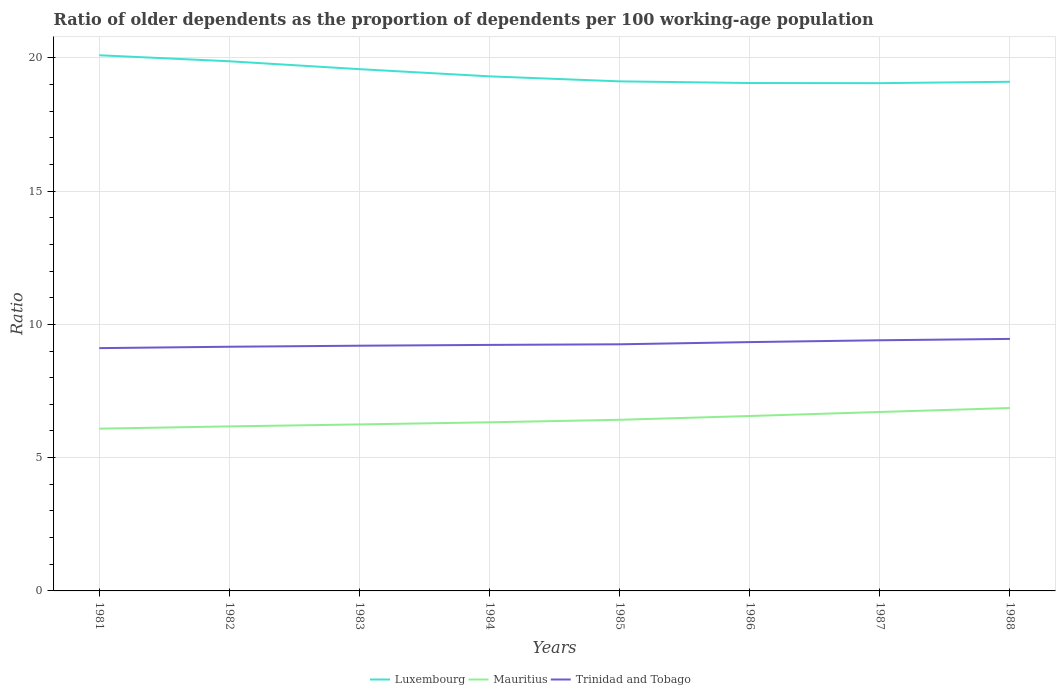How many different coloured lines are there?
Your response must be concise. 3. Is the number of lines equal to the number of legend labels?
Your response must be concise. Yes. Across all years, what is the maximum age dependency ratio(old) in Trinidad and Tobago?
Keep it short and to the point. 9.11. What is the total age dependency ratio(old) in Mauritius in the graph?
Offer a very short reply. -0.39. What is the difference between the highest and the second highest age dependency ratio(old) in Luxembourg?
Offer a very short reply. 1.05. What is the difference between the highest and the lowest age dependency ratio(old) in Luxembourg?
Make the answer very short. 3. Is the age dependency ratio(old) in Trinidad and Tobago strictly greater than the age dependency ratio(old) in Mauritius over the years?
Give a very brief answer. No. Are the values on the major ticks of Y-axis written in scientific E-notation?
Provide a succinct answer. No. What is the title of the graph?
Provide a short and direct response. Ratio of older dependents as the proportion of dependents per 100 working-age population. Does "Low income" appear as one of the legend labels in the graph?
Offer a terse response. No. What is the label or title of the Y-axis?
Your answer should be very brief. Ratio. What is the Ratio in Luxembourg in 1981?
Keep it short and to the point. 20.1. What is the Ratio in Mauritius in 1981?
Ensure brevity in your answer.  6.09. What is the Ratio of Trinidad and Tobago in 1981?
Keep it short and to the point. 9.11. What is the Ratio in Luxembourg in 1982?
Keep it short and to the point. 19.87. What is the Ratio in Mauritius in 1982?
Ensure brevity in your answer.  6.17. What is the Ratio of Trinidad and Tobago in 1982?
Offer a terse response. 9.16. What is the Ratio in Luxembourg in 1983?
Make the answer very short. 19.57. What is the Ratio in Mauritius in 1983?
Keep it short and to the point. 6.25. What is the Ratio of Trinidad and Tobago in 1983?
Keep it short and to the point. 9.2. What is the Ratio in Luxembourg in 1984?
Your answer should be very brief. 19.3. What is the Ratio in Mauritius in 1984?
Provide a short and direct response. 6.33. What is the Ratio of Trinidad and Tobago in 1984?
Your answer should be very brief. 9.23. What is the Ratio in Luxembourg in 1985?
Offer a terse response. 19.12. What is the Ratio of Mauritius in 1985?
Keep it short and to the point. 6.42. What is the Ratio of Trinidad and Tobago in 1985?
Your answer should be compact. 9.25. What is the Ratio of Luxembourg in 1986?
Give a very brief answer. 19.05. What is the Ratio in Mauritius in 1986?
Provide a succinct answer. 6.56. What is the Ratio of Trinidad and Tobago in 1986?
Keep it short and to the point. 9.33. What is the Ratio of Luxembourg in 1987?
Provide a succinct answer. 19.05. What is the Ratio in Mauritius in 1987?
Offer a terse response. 6.71. What is the Ratio in Trinidad and Tobago in 1987?
Make the answer very short. 9.4. What is the Ratio in Luxembourg in 1988?
Offer a very short reply. 19.1. What is the Ratio of Mauritius in 1988?
Your answer should be very brief. 6.86. What is the Ratio of Trinidad and Tobago in 1988?
Keep it short and to the point. 9.45. Across all years, what is the maximum Ratio in Luxembourg?
Your response must be concise. 20.1. Across all years, what is the maximum Ratio of Mauritius?
Your answer should be very brief. 6.86. Across all years, what is the maximum Ratio of Trinidad and Tobago?
Ensure brevity in your answer.  9.45. Across all years, what is the minimum Ratio of Luxembourg?
Make the answer very short. 19.05. Across all years, what is the minimum Ratio in Mauritius?
Ensure brevity in your answer.  6.09. Across all years, what is the minimum Ratio in Trinidad and Tobago?
Your response must be concise. 9.11. What is the total Ratio in Luxembourg in the graph?
Provide a succinct answer. 155.16. What is the total Ratio in Mauritius in the graph?
Keep it short and to the point. 51.39. What is the total Ratio in Trinidad and Tobago in the graph?
Your answer should be very brief. 74.14. What is the difference between the Ratio in Luxembourg in 1981 and that in 1982?
Keep it short and to the point. 0.23. What is the difference between the Ratio of Mauritius in 1981 and that in 1982?
Provide a short and direct response. -0.09. What is the difference between the Ratio in Trinidad and Tobago in 1981 and that in 1982?
Make the answer very short. -0.05. What is the difference between the Ratio of Luxembourg in 1981 and that in 1983?
Make the answer very short. 0.52. What is the difference between the Ratio in Mauritius in 1981 and that in 1983?
Your response must be concise. -0.16. What is the difference between the Ratio of Trinidad and Tobago in 1981 and that in 1983?
Offer a terse response. -0.09. What is the difference between the Ratio in Luxembourg in 1981 and that in 1984?
Your response must be concise. 0.79. What is the difference between the Ratio in Mauritius in 1981 and that in 1984?
Keep it short and to the point. -0.24. What is the difference between the Ratio in Trinidad and Tobago in 1981 and that in 1984?
Provide a succinct answer. -0.12. What is the difference between the Ratio of Luxembourg in 1981 and that in 1985?
Keep it short and to the point. 0.98. What is the difference between the Ratio in Mauritius in 1981 and that in 1985?
Offer a very short reply. -0.33. What is the difference between the Ratio in Trinidad and Tobago in 1981 and that in 1985?
Ensure brevity in your answer.  -0.14. What is the difference between the Ratio of Luxembourg in 1981 and that in 1986?
Offer a terse response. 1.04. What is the difference between the Ratio in Mauritius in 1981 and that in 1986?
Offer a terse response. -0.48. What is the difference between the Ratio of Trinidad and Tobago in 1981 and that in 1986?
Ensure brevity in your answer.  -0.23. What is the difference between the Ratio in Luxembourg in 1981 and that in 1987?
Ensure brevity in your answer.  1.05. What is the difference between the Ratio of Mauritius in 1981 and that in 1987?
Your answer should be compact. -0.63. What is the difference between the Ratio of Trinidad and Tobago in 1981 and that in 1987?
Give a very brief answer. -0.29. What is the difference between the Ratio of Mauritius in 1981 and that in 1988?
Offer a terse response. -0.77. What is the difference between the Ratio in Trinidad and Tobago in 1981 and that in 1988?
Your answer should be very brief. -0.35. What is the difference between the Ratio in Luxembourg in 1982 and that in 1983?
Your response must be concise. 0.3. What is the difference between the Ratio in Mauritius in 1982 and that in 1983?
Make the answer very short. -0.07. What is the difference between the Ratio in Trinidad and Tobago in 1982 and that in 1983?
Offer a very short reply. -0.04. What is the difference between the Ratio in Luxembourg in 1982 and that in 1984?
Keep it short and to the point. 0.57. What is the difference between the Ratio of Mauritius in 1982 and that in 1984?
Your answer should be very brief. -0.15. What is the difference between the Ratio of Trinidad and Tobago in 1982 and that in 1984?
Offer a very short reply. -0.07. What is the difference between the Ratio of Luxembourg in 1982 and that in 1985?
Offer a terse response. 0.75. What is the difference between the Ratio in Mauritius in 1982 and that in 1985?
Your answer should be compact. -0.25. What is the difference between the Ratio of Trinidad and Tobago in 1982 and that in 1985?
Provide a short and direct response. -0.09. What is the difference between the Ratio of Luxembourg in 1982 and that in 1986?
Keep it short and to the point. 0.82. What is the difference between the Ratio in Mauritius in 1982 and that in 1986?
Keep it short and to the point. -0.39. What is the difference between the Ratio of Trinidad and Tobago in 1982 and that in 1986?
Your answer should be compact. -0.17. What is the difference between the Ratio of Luxembourg in 1982 and that in 1987?
Provide a succinct answer. 0.82. What is the difference between the Ratio in Mauritius in 1982 and that in 1987?
Provide a succinct answer. -0.54. What is the difference between the Ratio in Trinidad and Tobago in 1982 and that in 1987?
Your response must be concise. -0.24. What is the difference between the Ratio in Luxembourg in 1982 and that in 1988?
Give a very brief answer. 0.77. What is the difference between the Ratio in Mauritius in 1982 and that in 1988?
Ensure brevity in your answer.  -0.69. What is the difference between the Ratio of Trinidad and Tobago in 1982 and that in 1988?
Make the answer very short. -0.29. What is the difference between the Ratio of Luxembourg in 1983 and that in 1984?
Offer a terse response. 0.27. What is the difference between the Ratio in Mauritius in 1983 and that in 1984?
Keep it short and to the point. -0.08. What is the difference between the Ratio of Trinidad and Tobago in 1983 and that in 1984?
Ensure brevity in your answer.  -0.03. What is the difference between the Ratio of Luxembourg in 1983 and that in 1985?
Your answer should be very brief. 0.46. What is the difference between the Ratio of Mauritius in 1983 and that in 1985?
Keep it short and to the point. -0.17. What is the difference between the Ratio in Trinidad and Tobago in 1983 and that in 1985?
Make the answer very short. -0.05. What is the difference between the Ratio of Luxembourg in 1983 and that in 1986?
Make the answer very short. 0.52. What is the difference between the Ratio of Mauritius in 1983 and that in 1986?
Provide a short and direct response. -0.32. What is the difference between the Ratio of Trinidad and Tobago in 1983 and that in 1986?
Your response must be concise. -0.14. What is the difference between the Ratio in Luxembourg in 1983 and that in 1987?
Your response must be concise. 0.52. What is the difference between the Ratio in Mauritius in 1983 and that in 1987?
Offer a terse response. -0.47. What is the difference between the Ratio in Trinidad and Tobago in 1983 and that in 1987?
Make the answer very short. -0.2. What is the difference between the Ratio in Luxembourg in 1983 and that in 1988?
Make the answer very short. 0.47. What is the difference between the Ratio of Mauritius in 1983 and that in 1988?
Your answer should be very brief. -0.61. What is the difference between the Ratio of Trinidad and Tobago in 1983 and that in 1988?
Your response must be concise. -0.25. What is the difference between the Ratio of Luxembourg in 1984 and that in 1985?
Your answer should be compact. 0.19. What is the difference between the Ratio in Mauritius in 1984 and that in 1985?
Your answer should be compact. -0.09. What is the difference between the Ratio of Trinidad and Tobago in 1984 and that in 1985?
Give a very brief answer. -0.02. What is the difference between the Ratio of Luxembourg in 1984 and that in 1986?
Give a very brief answer. 0.25. What is the difference between the Ratio of Mauritius in 1984 and that in 1986?
Ensure brevity in your answer.  -0.24. What is the difference between the Ratio in Trinidad and Tobago in 1984 and that in 1986?
Provide a succinct answer. -0.11. What is the difference between the Ratio of Luxembourg in 1984 and that in 1987?
Offer a terse response. 0.26. What is the difference between the Ratio of Mauritius in 1984 and that in 1987?
Offer a very short reply. -0.39. What is the difference between the Ratio in Trinidad and Tobago in 1984 and that in 1987?
Your answer should be very brief. -0.17. What is the difference between the Ratio in Luxembourg in 1984 and that in 1988?
Ensure brevity in your answer.  0.2. What is the difference between the Ratio of Mauritius in 1984 and that in 1988?
Make the answer very short. -0.54. What is the difference between the Ratio of Trinidad and Tobago in 1984 and that in 1988?
Provide a succinct answer. -0.23. What is the difference between the Ratio in Luxembourg in 1985 and that in 1986?
Your response must be concise. 0.06. What is the difference between the Ratio in Mauritius in 1985 and that in 1986?
Keep it short and to the point. -0.14. What is the difference between the Ratio in Trinidad and Tobago in 1985 and that in 1986?
Offer a terse response. -0.08. What is the difference between the Ratio of Luxembourg in 1985 and that in 1987?
Provide a succinct answer. 0.07. What is the difference between the Ratio in Mauritius in 1985 and that in 1987?
Ensure brevity in your answer.  -0.29. What is the difference between the Ratio of Trinidad and Tobago in 1985 and that in 1987?
Keep it short and to the point. -0.15. What is the difference between the Ratio of Luxembourg in 1985 and that in 1988?
Ensure brevity in your answer.  0.02. What is the difference between the Ratio of Mauritius in 1985 and that in 1988?
Provide a short and direct response. -0.44. What is the difference between the Ratio in Trinidad and Tobago in 1985 and that in 1988?
Your response must be concise. -0.2. What is the difference between the Ratio in Luxembourg in 1986 and that in 1987?
Provide a succinct answer. 0.01. What is the difference between the Ratio of Mauritius in 1986 and that in 1987?
Your response must be concise. -0.15. What is the difference between the Ratio of Trinidad and Tobago in 1986 and that in 1987?
Ensure brevity in your answer.  -0.07. What is the difference between the Ratio in Luxembourg in 1986 and that in 1988?
Make the answer very short. -0.05. What is the difference between the Ratio in Mauritius in 1986 and that in 1988?
Give a very brief answer. -0.3. What is the difference between the Ratio of Trinidad and Tobago in 1986 and that in 1988?
Your answer should be very brief. -0.12. What is the difference between the Ratio of Luxembourg in 1987 and that in 1988?
Your answer should be compact. -0.05. What is the difference between the Ratio in Mauritius in 1987 and that in 1988?
Keep it short and to the point. -0.15. What is the difference between the Ratio in Trinidad and Tobago in 1987 and that in 1988?
Your answer should be compact. -0.05. What is the difference between the Ratio in Luxembourg in 1981 and the Ratio in Mauritius in 1982?
Your answer should be very brief. 13.92. What is the difference between the Ratio in Luxembourg in 1981 and the Ratio in Trinidad and Tobago in 1982?
Provide a short and direct response. 10.93. What is the difference between the Ratio in Mauritius in 1981 and the Ratio in Trinidad and Tobago in 1982?
Your response must be concise. -3.07. What is the difference between the Ratio in Luxembourg in 1981 and the Ratio in Mauritius in 1983?
Give a very brief answer. 13.85. What is the difference between the Ratio in Luxembourg in 1981 and the Ratio in Trinidad and Tobago in 1983?
Make the answer very short. 10.9. What is the difference between the Ratio in Mauritius in 1981 and the Ratio in Trinidad and Tobago in 1983?
Your answer should be compact. -3.11. What is the difference between the Ratio of Luxembourg in 1981 and the Ratio of Mauritius in 1984?
Keep it short and to the point. 13.77. What is the difference between the Ratio in Luxembourg in 1981 and the Ratio in Trinidad and Tobago in 1984?
Offer a very short reply. 10.87. What is the difference between the Ratio in Mauritius in 1981 and the Ratio in Trinidad and Tobago in 1984?
Ensure brevity in your answer.  -3.14. What is the difference between the Ratio in Luxembourg in 1981 and the Ratio in Mauritius in 1985?
Your response must be concise. 13.68. What is the difference between the Ratio in Luxembourg in 1981 and the Ratio in Trinidad and Tobago in 1985?
Ensure brevity in your answer.  10.84. What is the difference between the Ratio of Mauritius in 1981 and the Ratio of Trinidad and Tobago in 1985?
Your answer should be very brief. -3.16. What is the difference between the Ratio of Luxembourg in 1981 and the Ratio of Mauritius in 1986?
Provide a short and direct response. 13.53. What is the difference between the Ratio of Luxembourg in 1981 and the Ratio of Trinidad and Tobago in 1986?
Your response must be concise. 10.76. What is the difference between the Ratio in Mauritius in 1981 and the Ratio in Trinidad and Tobago in 1986?
Your answer should be very brief. -3.25. What is the difference between the Ratio in Luxembourg in 1981 and the Ratio in Mauritius in 1987?
Your answer should be compact. 13.38. What is the difference between the Ratio in Luxembourg in 1981 and the Ratio in Trinidad and Tobago in 1987?
Your response must be concise. 10.69. What is the difference between the Ratio in Mauritius in 1981 and the Ratio in Trinidad and Tobago in 1987?
Offer a very short reply. -3.32. What is the difference between the Ratio in Luxembourg in 1981 and the Ratio in Mauritius in 1988?
Your answer should be very brief. 13.23. What is the difference between the Ratio of Luxembourg in 1981 and the Ratio of Trinidad and Tobago in 1988?
Ensure brevity in your answer.  10.64. What is the difference between the Ratio in Mauritius in 1981 and the Ratio in Trinidad and Tobago in 1988?
Provide a short and direct response. -3.37. What is the difference between the Ratio of Luxembourg in 1982 and the Ratio of Mauritius in 1983?
Provide a succinct answer. 13.62. What is the difference between the Ratio of Luxembourg in 1982 and the Ratio of Trinidad and Tobago in 1983?
Your answer should be very brief. 10.67. What is the difference between the Ratio of Mauritius in 1982 and the Ratio of Trinidad and Tobago in 1983?
Provide a short and direct response. -3.03. What is the difference between the Ratio of Luxembourg in 1982 and the Ratio of Mauritius in 1984?
Keep it short and to the point. 13.54. What is the difference between the Ratio in Luxembourg in 1982 and the Ratio in Trinidad and Tobago in 1984?
Give a very brief answer. 10.64. What is the difference between the Ratio in Mauritius in 1982 and the Ratio in Trinidad and Tobago in 1984?
Make the answer very short. -3.06. What is the difference between the Ratio of Luxembourg in 1982 and the Ratio of Mauritius in 1985?
Your response must be concise. 13.45. What is the difference between the Ratio in Luxembourg in 1982 and the Ratio in Trinidad and Tobago in 1985?
Offer a very short reply. 10.62. What is the difference between the Ratio of Mauritius in 1982 and the Ratio of Trinidad and Tobago in 1985?
Provide a short and direct response. -3.08. What is the difference between the Ratio of Luxembourg in 1982 and the Ratio of Mauritius in 1986?
Keep it short and to the point. 13.31. What is the difference between the Ratio in Luxembourg in 1982 and the Ratio in Trinidad and Tobago in 1986?
Offer a very short reply. 10.53. What is the difference between the Ratio of Mauritius in 1982 and the Ratio of Trinidad and Tobago in 1986?
Your answer should be compact. -3.16. What is the difference between the Ratio of Luxembourg in 1982 and the Ratio of Mauritius in 1987?
Give a very brief answer. 13.16. What is the difference between the Ratio in Luxembourg in 1982 and the Ratio in Trinidad and Tobago in 1987?
Your answer should be very brief. 10.47. What is the difference between the Ratio of Mauritius in 1982 and the Ratio of Trinidad and Tobago in 1987?
Your answer should be very brief. -3.23. What is the difference between the Ratio in Luxembourg in 1982 and the Ratio in Mauritius in 1988?
Make the answer very short. 13.01. What is the difference between the Ratio of Luxembourg in 1982 and the Ratio of Trinidad and Tobago in 1988?
Make the answer very short. 10.42. What is the difference between the Ratio of Mauritius in 1982 and the Ratio of Trinidad and Tobago in 1988?
Keep it short and to the point. -3.28. What is the difference between the Ratio of Luxembourg in 1983 and the Ratio of Mauritius in 1984?
Keep it short and to the point. 13.25. What is the difference between the Ratio of Luxembourg in 1983 and the Ratio of Trinidad and Tobago in 1984?
Keep it short and to the point. 10.34. What is the difference between the Ratio of Mauritius in 1983 and the Ratio of Trinidad and Tobago in 1984?
Provide a succinct answer. -2.98. What is the difference between the Ratio in Luxembourg in 1983 and the Ratio in Mauritius in 1985?
Your answer should be compact. 13.15. What is the difference between the Ratio of Luxembourg in 1983 and the Ratio of Trinidad and Tobago in 1985?
Keep it short and to the point. 10.32. What is the difference between the Ratio in Mauritius in 1983 and the Ratio in Trinidad and Tobago in 1985?
Offer a terse response. -3.01. What is the difference between the Ratio in Luxembourg in 1983 and the Ratio in Mauritius in 1986?
Keep it short and to the point. 13.01. What is the difference between the Ratio in Luxembourg in 1983 and the Ratio in Trinidad and Tobago in 1986?
Your answer should be compact. 10.24. What is the difference between the Ratio in Mauritius in 1983 and the Ratio in Trinidad and Tobago in 1986?
Ensure brevity in your answer.  -3.09. What is the difference between the Ratio in Luxembourg in 1983 and the Ratio in Mauritius in 1987?
Offer a terse response. 12.86. What is the difference between the Ratio of Luxembourg in 1983 and the Ratio of Trinidad and Tobago in 1987?
Your response must be concise. 10.17. What is the difference between the Ratio in Mauritius in 1983 and the Ratio in Trinidad and Tobago in 1987?
Ensure brevity in your answer.  -3.16. What is the difference between the Ratio in Luxembourg in 1983 and the Ratio in Mauritius in 1988?
Your answer should be very brief. 12.71. What is the difference between the Ratio of Luxembourg in 1983 and the Ratio of Trinidad and Tobago in 1988?
Your answer should be very brief. 10.12. What is the difference between the Ratio in Mauritius in 1983 and the Ratio in Trinidad and Tobago in 1988?
Provide a short and direct response. -3.21. What is the difference between the Ratio of Luxembourg in 1984 and the Ratio of Mauritius in 1985?
Ensure brevity in your answer.  12.88. What is the difference between the Ratio of Luxembourg in 1984 and the Ratio of Trinidad and Tobago in 1985?
Offer a very short reply. 10.05. What is the difference between the Ratio of Mauritius in 1984 and the Ratio of Trinidad and Tobago in 1985?
Offer a very short reply. -2.93. What is the difference between the Ratio of Luxembourg in 1984 and the Ratio of Mauritius in 1986?
Your answer should be very brief. 12.74. What is the difference between the Ratio in Luxembourg in 1984 and the Ratio in Trinidad and Tobago in 1986?
Give a very brief answer. 9.97. What is the difference between the Ratio in Mauritius in 1984 and the Ratio in Trinidad and Tobago in 1986?
Provide a short and direct response. -3.01. What is the difference between the Ratio in Luxembourg in 1984 and the Ratio in Mauritius in 1987?
Your response must be concise. 12.59. What is the difference between the Ratio in Luxembourg in 1984 and the Ratio in Trinidad and Tobago in 1987?
Give a very brief answer. 9.9. What is the difference between the Ratio in Mauritius in 1984 and the Ratio in Trinidad and Tobago in 1987?
Give a very brief answer. -3.08. What is the difference between the Ratio of Luxembourg in 1984 and the Ratio of Mauritius in 1988?
Your response must be concise. 12.44. What is the difference between the Ratio of Luxembourg in 1984 and the Ratio of Trinidad and Tobago in 1988?
Your response must be concise. 9.85. What is the difference between the Ratio in Mauritius in 1984 and the Ratio in Trinidad and Tobago in 1988?
Your response must be concise. -3.13. What is the difference between the Ratio of Luxembourg in 1985 and the Ratio of Mauritius in 1986?
Keep it short and to the point. 12.55. What is the difference between the Ratio in Luxembourg in 1985 and the Ratio in Trinidad and Tobago in 1986?
Make the answer very short. 9.78. What is the difference between the Ratio of Mauritius in 1985 and the Ratio of Trinidad and Tobago in 1986?
Provide a short and direct response. -2.91. What is the difference between the Ratio in Luxembourg in 1985 and the Ratio in Mauritius in 1987?
Your response must be concise. 12.4. What is the difference between the Ratio in Luxembourg in 1985 and the Ratio in Trinidad and Tobago in 1987?
Ensure brevity in your answer.  9.71. What is the difference between the Ratio of Mauritius in 1985 and the Ratio of Trinidad and Tobago in 1987?
Your answer should be compact. -2.98. What is the difference between the Ratio in Luxembourg in 1985 and the Ratio in Mauritius in 1988?
Your response must be concise. 12.25. What is the difference between the Ratio in Luxembourg in 1985 and the Ratio in Trinidad and Tobago in 1988?
Offer a terse response. 9.66. What is the difference between the Ratio in Mauritius in 1985 and the Ratio in Trinidad and Tobago in 1988?
Offer a very short reply. -3.03. What is the difference between the Ratio in Luxembourg in 1986 and the Ratio in Mauritius in 1987?
Offer a very short reply. 12.34. What is the difference between the Ratio of Luxembourg in 1986 and the Ratio of Trinidad and Tobago in 1987?
Give a very brief answer. 9.65. What is the difference between the Ratio of Mauritius in 1986 and the Ratio of Trinidad and Tobago in 1987?
Ensure brevity in your answer.  -2.84. What is the difference between the Ratio in Luxembourg in 1986 and the Ratio in Mauritius in 1988?
Your response must be concise. 12.19. What is the difference between the Ratio in Luxembourg in 1986 and the Ratio in Trinidad and Tobago in 1988?
Offer a terse response. 9.6. What is the difference between the Ratio of Mauritius in 1986 and the Ratio of Trinidad and Tobago in 1988?
Give a very brief answer. -2.89. What is the difference between the Ratio in Luxembourg in 1987 and the Ratio in Mauritius in 1988?
Ensure brevity in your answer.  12.19. What is the difference between the Ratio of Luxembourg in 1987 and the Ratio of Trinidad and Tobago in 1988?
Your answer should be very brief. 9.59. What is the difference between the Ratio of Mauritius in 1987 and the Ratio of Trinidad and Tobago in 1988?
Offer a very short reply. -2.74. What is the average Ratio of Luxembourg per year?
Keep it short and to the point. 19.4. What is the average Ratio in Mauritius per year?
Your response must be concise. 6.42. What is the average Ratio in Trinidad and Tobago per year?
Give a very brief answer. 9.27. In the year 1981, what is the difference between the Ratio of Luxembourg and Ratio of Mauritius?
Offer a terse response. 14.01. In the year 1981, what is the difference between the Ratio in Luxembourg and Ratio in Trinidad and Tobago?
Ensure brevity in your answer.  10.99. In the year 1981, what is the difference between the Ratio of Mauritius and Ratio of Trinidad and Tobago?
Your answer should be very brief. -3.02. In the year 1982, what is the difference between the Ratio of Luxembourg and Ratio of Mauritius?
Your response must be concise. 13.7. In the year 1982, what is the difference between the Ratio of Luxembourg and Ratio of Trinidad and Tobago?
Your answer should be compact. 10.71. In the year 1982, what is the difference between the Ratio in Mauritius and Ratio in Trinidad and Tobago?
Provide a short and direct response. -2.99. In the year 1983, what is the difference between the Ratio in Luxembourg and Ratio in Mauritius?
Keep it short and to the point. 13.33. In the year 1983, what is the difference between the Ratio in Luxembourg and Ratio in Trinidad and Tobago?
Offer a terse response. 10.37. In the year 1983, what is the difference between the Ratio in Mauritius and Ratio in Trinidad and Tobago?
Give a very brief answer. -2.95. In the year 1984, what is the difference between the Ratio in Luxembourg and Ratio in Mauritius?
Keep it short and to the point. 12.98. In the year 1984, what is the difference between the Ratio of Luxembourg and Ratio of Trinidad and Tobago?
Your answer should be very brief. 10.07. In the year 1984, what is the difference between the Ratio of Mauritius and Ratio of Trinidad and Tobago?
Offer a terse response. -2.9. In the year 1985, what is the difference between the Ratio of Luxembourg and Ratio of Mauritius?
Ensure brevity in your answer.  12.7. In the year 1985, what is the difference between the Ratio in Luxembourg and Ratio in Trinidad and Tobago?
Provide a short and direct response. 9.86. In the year 1985, what is the difference between the Ratio of Mauritius and Ratio of Trinidad and Tobago?
Give a very brief answer. -2.83. In the year 1986, what is the difference between the Ratio in Luxembourg and Ratio in Mauritius?
Offer a very short reply. 12.49. In the year 1986, what is the difference between the Ratio of Luxembourg and Ratio of Trinidad and Tobago?
Make the answer very short. 9.72. In the year 1986, what is the difference between the Ratio of Mauritius and Ratio of Trinidad and Tobago?
Your answer should be compact. -2.77. In the year 1987, what is the difference between the Ratio in Luxembourg and Ratio in Mauritius?
Your response must be concise. 12.34. In the year 1987, what is the difference between the Ratio of Luxembourg and Ratio of Trinidad and Tobago?
Make the answer very short. 9.65. In the year 1987, what is the difference between the Ratio of Mauritius and Ratio of Trinidad and Tobago?
Provide a succinct answer. -2.69. In the year 1988, what is the difference between the Ratio of Luxembourg and Ratio of Mauritius?
Your response must be concise. 12.24. In the year 1988, what is the difference between the Ratio in Luxembourg and Ratio in Trinidad and Tobago?
Provide a short and direct response. 9.65. In the year 1988, what is the difference between the Ratio of Mauritius and Ratio of Trinidad and Tobago?
Your answer should be very brief. -2.59. What is the ratio of the Ratio in Luxembourg in 1981 to that in 1982?
Provide a short and direct response. 1.01. What is the ratio of the Ratio in Mauritius in 1981 to that in 1982?
Provide a succinct answer. 0.99. What is the ratio of the Ratio of Luxembourg in 1981 to that in 1983?
Your response must be concise. 1.03. What is the ratio of the Ratio of Mauritius in 1981 to that in 1983?
Keep it short and to the point. 0.97. What is the ratio of the Ratio of Luxembourg in 1981 to that in 1984?
Keep it short and to the point. 1.04. What is the ratio of the Ratio of Mauritius in 1981 to that in 1984?
Give a very brief answer. 0.96. What is the ratio of the Ratio of Trinidad and Tobago in 1981 to that in 1984?
Offer a terse response. 0.99. What is the ratio of the Ratio in Luxembourg in 1981 to that in 1985?
Keep it short and to the point. 1.05. What is the ratio of the Ratio of Mauritius in 1981 to that in 1985?
Give a very brief answer. 0.95. What is the ratio of the Ratio of Trinidad and Tobago in 1981 to that in 1985?
Your response must be concise. 0.98. What is the ratio of the Ratio of Luxembourg in 1981 to that in 1986?
Your response must be concise. 1.05. What is the ratio of the Ratio of Mauritius in 1981 to that in 1986?
Your answer should be compact. 0.93. What is the ratio of the Ratio in Trinidad and Tobago in 1981 to that in 1986?
Provide a succinct answer. 0.98. What is the ratio of the Ratio of Luxembourg in 1981 to that in 1987?
Offer a very short reply. 1.05. What is the ratio of the Ratio in Mauritius in 1981 to that in 1987?
Your answer should be very brief. 0.91. What is the ratio of the Ratio of Trinidad and Tobago in 1981 to that in 1987?
Your answer should be compact. 0.97. What is the ratio of the Ratio in Luxembourg in 1981 to that in 1988?
Ensure brevity in your answer.  1.05. What is the ratio of the Ratio in Mauritius in 1981 to that in 1988?
Give a very brief answer. 0.89. What is the ratio of the Ratio in Trinidad and Tobago in 1981 to that in 1988?
Provide a short and direct response. 0.96. What is the ratio of the Ratio in Luxembourg in 1982 to that in 1983?
Offer a terse response. 1.02. What is the ratio of the Ratio in Luxembourg in 1982 to that in 1984?
Your answer should be compact. 1.03. What is the ratio of the Ratio in Mauritius in 1982 to that in 1984?
Keep it short and to the point. 0.98. What is the ratio of the Ratio in Trinidad and Tobago in 1982 to that in 1984?
Offer a very short reply. 0.99. What is the ratio of the Ratio in Luxembourg in 1982 to that in 1985?
Your response must be concise. 1.04. What is the ratio of the Ratio of Mauritius in 1982 to that in 1985?
Your answer should be very brief. 0.96. What is the ratio of the Ratio in Trinidad and Tobago in 1982 to that in 1985?
Make the answer very short. 0.99. What is the ratio of the Ratio in Luxembourg in 1982 to that in 1986?
Offer a very short reply. 1.04. What is the ratio of the Ratio of Mauritius in 1982 to that in 1986?
Ensure brevity in your answer.  0.94. What is the ratio of the Ratio of Trinidad and Tobago in 1982 to that in 1986?
Your response must be concise. 0.98. What is the ratio of the Ratio in Luxembourg in 1982 to that in 1987?
Provide a short and direct response. 1.04. What is the ratio of the Ratio in Mauritius in 1982 to that in 1987?
Make the answer very short. 0.92. What is the ratio of the Ratio in Trinidad and Tobago in 1982 to that in 1987?
Ensure brevity in your answer.  0.97. What is the ratio of the Ratio in Luxembourg in 1982 to that in 1988?
Keep it short and to the point. 1.04. What is the ratio of the Ratio in Mauritius in 1982 to that in 1988?
Give a very brief answer. 0.9. What is the ratio of the Ratio of Trinidad and Tobago in 1982 to that in 1988?
Provide a short and direct response. 0.97. What is the ratio of the Ratio of Luxembourg in 1983 to that in 1984?
Your answer should be compact. 1.01. What is the ratio of the Ratio of Mauritius in 1983 to that in 1984?
Keep it short and to the point. 0.99. What is the ratio of the Ratio of Trinidad and Tobago in 1983 to that in 1984?
Your answer should be very brief. 1. What is the ratio of the Ratio of Luxembourg in 1983 to that in 1985?
Your response must be concise. 1.02. What is the ratio of the Ratio in Mauritius in 1983 to that in 1985?
Give a very brief answer. 0.97. What is the ratio of the Ratio in Luxembourg in 1983 to that in 1986?
Give a very brief answer. 1.03. What is the ratio of the Ratio in Mauritius in 1983 to that in 1986?
Give a very brief answer. 0.95. What is the ratio of the Ratio of Trinidad and Tobago in 1983 to that in 1986?
Offer a terse response. 0.99. What is the ratio of the Ratio of Luxembourg in 1983 to that in 1987?
Offer a terse response. 1.03. What is the ratio of the Ratio of Mauritius in 1983 to that in 1987?
Ensure brevity in your answer.  0.93. What is the ratio of the Ratio in Trinidad and Tobago in 1983 to that in 1987?
Your answer should be compact. 0.98. What is the ratio of the Ratio in Luxembourg in 1983 to that in 1988?
Keep it short and to the point. 1.02. What is the ratio of the Ratio in Mauritius in 1983 to that in 1988?
Give a very brief answer. 0.91. What is the ratio of the Ratio of Luxembourg in 1984 to that in 1985?
Your answer should be compact. 1.01. What is the ratio of the Ratio of Mauritius in 1984 to that in 1985?
Give a very brief answer. 0.99. What is the ratio of the Ratio of Trinidad and Tobago in 1984 to that in 1985?
Make the answer very short. 1. What is the ratio of the Ratio of Luxembourg in 1984 to that in 1986?
Provide a short and direct response. 1.01. What is the ratio of the Ratio in Mauritius in 1984 to that in 1986?
Offer a very short reply. 0.96. What is the ratio of the Ratio in Trinidad and Tobago in 1984 to that in 1986?
Your answer should be very brief. 0.99. What is the ratio of the Ratio in Luxembourg in 1984 to that in 1987?
Give a very brief answer. 1.01. What is the ratio of the Ratio of Mauritius in 1984 to that in 1987?
Your answer should be compact. 0.94. What is the ratio of the Ratio of Trinidad and Tobago in 1984 to that in 1987?
Your answer should be compact. 0.98. What is the ratio of the Ratio in Luxembourg in 1984 to that in 1988?
Make the answer very short. 1.01. What is the ratio of the Ratio of Mauritius in 1984 to that in 1988?
Your response must be concise. 0.92. What is the ratio of the Ratio of Trinidad and Tobago in 1984 to that in 1988?
Give a very brief answer. 0.98. What is the ratio of the Ratio of Mauritius in 1985 to that in 1986?
Provide a short and direct response. 0.98. What is the ratio of the Ratio in Trinidad and Tobago in 1985 to that in 1986?
Your answer should be very brief. 0.99. What is the ratio of the Ratio of Luxembourg in 1985 to that in 1987?
Provide a succinct answer. 1. What is the ratio of the Ratio of Mauritius in 1985 to that in 1987?
Provide a succinct answer. 0.96. What is the ratio of the Ratio of Trinidad and Tobago in 1985 to that in 1987?
Give a very brief answer. 0.98. What is the ratio of the Ratio of Luxembourg in 1985 to that in 1988?
Keep it short and to the point. 1. What is the ratio of the Ratio in Mauritius in 1985 to that in 1988?
Provide a short and direct response. 0.94. What is the ratio of the Ratio in Trinidad and Tobago in 1985 to that in 1988?
Your response must be concise. 0.98. What is the ratio of the Ratio of Mauritius in 1986 to that in 1987?
Your response must be concise. 0.98. What is the ratio of the Ratio of Luxembourg in 1986 to that in 1988?
Keep it short and to the point. 1. What is the ratio of the Ratio in Mauritius in 1986 to that in 1988?
Offer a very short reply. 0.96. What is the ratio of the Ratio in Trinidad and Tobago in 1986 to that in 1988?
Your answer should be very brief. 0.99. What is the ratio of the Ratio in Mauritius in 1987 to that in 1988?
Provide a succinct answer. 0.98. What is the difference between the highest and the second highest Ratio in Luxembourg?
Keep it short and to the point. 0.23. What is the difference between the highest and the second highest Ratio in Mauritius?
Provide a short and direct response. 0.15. What is the difference between the highest and the second highest Ratio of Trinidad and Tobago?
Offer a very short reply. 0.05. What is the difference between the highest and the lowest Ratio of Luxembourg?
Give a very brief answer. 1.05. What is the difference between the highest and the lowest Ratio of Mauritius?
Offer a very short reply. 0.77. What is the difference between the highest and the lowest Ratio in Trinidad and Tobago?
Provide a short and direct response. 0.35. 